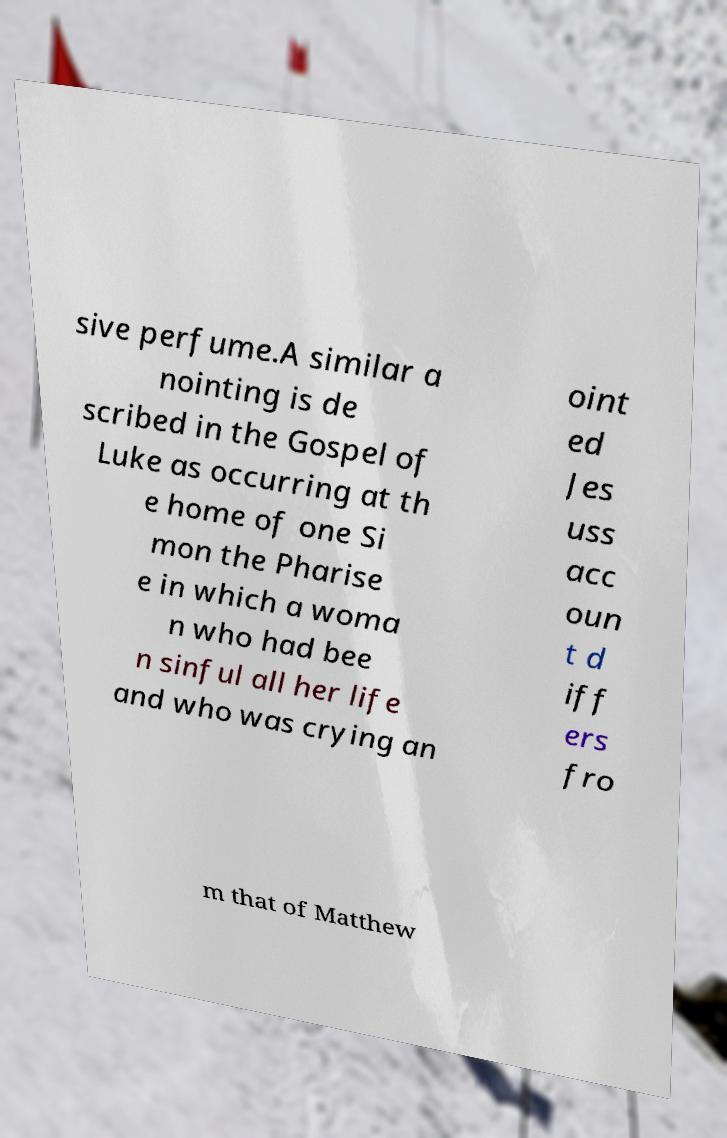Can you accurately transcribe the text from the provided image for me? sive perfume.A similar a nointing is de scribed in the Gospel of Luke as occurring at th e home of one Si mon the Pharise e in which a woma n who had bee n sinful all her life and who was crying an oint ed Jes uss acc oun t d iff ers fro m that of Matthew 